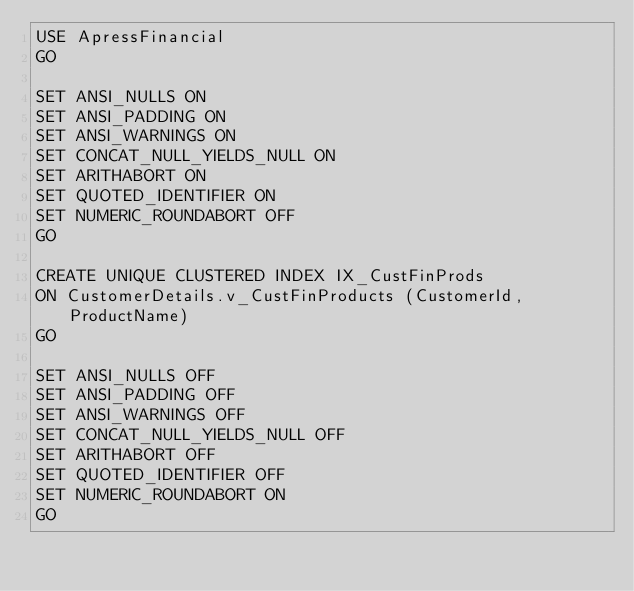Convert code to text. <code><loc_0><loc_0><loc_500><loc_500><_SQL_>USE ApressFinancial
GO

SET ANSI_NULLS ON
SET ANSI_PADDING ON
SET ANSI_WARNINGS ON
SET CONCAT_NULL_YIELDS_NULL ON
SET ARITHABORT ON
SET QUOTED_IDENTIFIER ON
SET NUMERIC_ROUNDABORT OFF
GO

CREATE UNIQUE CLUSTERED INDEX IX_CustFinProds
ON CustomerDetails.v_CustFinProducts (CustomerId, ProductName)
GO

SET ANSI_NULLS OFF
SET ANSI_PADDING OFF
SET ANSI_WARNINGS OFF
SET CONCAT_NULL_YIELDS_NULL OFF
SET ARITHABORT OFF
SET QUOTED_IDENTIFIER OFF
SET NUMERIC_ROUNDABORT ON
GO</code> 